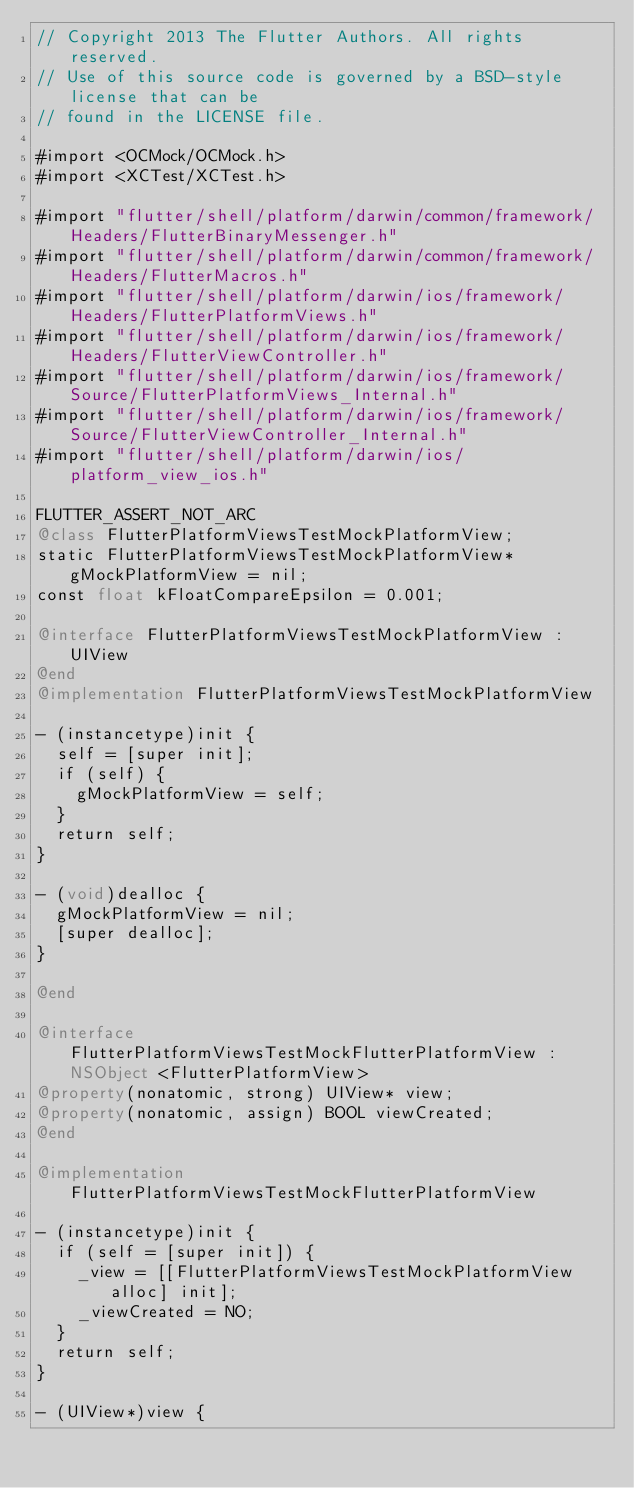<code> <loc_0><loc_0><loc_500><loc_500><_ObjectiveC_>// Copyright 2013 The Flutter Authors. All rights reserved.
// Use of this source code is governed by a BSD-style license that can be
// found in the LICENSE file.

#import <OCMock/OCMock.h>
#import <XCTest/XCTest.h>

#import "flutter/shell/platform/darwin/common/framework/Headers/FlutterBinaryMessenger.h"
#import "flutter/shell/platform/darwin/common/framework/Headers/FlutterMacros.h"
#import "flutter/shell/platform/darwin/ios/framework/Headers/FlutterPlatformViews.h"
#import "flutter/shell/platform/darwin/ios/framework/Headers/FlutterViewController.h"
#import "flutter/shell/platform/darwin/ios/framework/Source/FlutterPlatformViews_Internal.h"
#import "flutter/shell/platform/darwin/ios/framework/Source/FlutterViewController_Internal.h"
#import "flutter/shell/platform/darwin/ios/platform_view_ios.h"

FLUTTER_ASSERT_NOT_ARC
@class FlutterPlatformViewsTestMockPlatformView;
static FlutterPlatformViewsTestMockPlatformView* gMockPlatformView = nil;
const float kFloatCompareEpsilon = 0.001;

@interface FlutterPlatformViewsTestMockPlatformView : UIView
@end
@implementation FlutterPlatformViewsTestMockPlatformView

- (instancetype)init {
  self = [super init];
  if (self) {
    gMockPlatformView = self;
  }
  return self;
}

- (void)dealloc {
  gMockPlatformView = nil;
  [super dealloc];
}

@end

@interface FlutterPlatformViewsTestMockFlutterPlatformView : NSObject <FlutterPlatformView>
@property(nonatomic, strong) UIView* view;
@property(nonatomic, assign) BOOL viewCreated;
@end

@implementation FlutterPlatformViewsTestMockFlutterPlatformView

- (instancetype)init {
  if (self = [super init]) {
    _view = [[FlutterPlatformViewsTestMockPlatformView alloc] init];
    _viewCreated = NO;
  }
  return self;
}

- (UIView*)view {</code> 